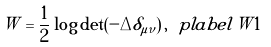Convert formula to latex. <formula><loc_0><loc_0><loc_500><loc_500>W = \frac { 1 } { 2 } \log \det ( - \Delta \delta _ { \mu \nu } ) \, , \ p l a b e l { W 1 }</formula> 